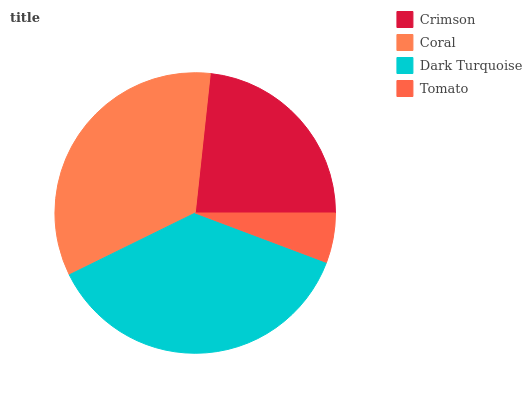Is Tomato the minimum?
Answer yes or no. Yes. Is Dark Turquoise the maximum?
Answer yes or no. Yes. Is Coral the minimum?
Answer yes or no. No. Is Coral the maximum?
Answer yes or no. No. Is Coral greater than Crimson?
Answer yes or no. Yes. Is Crimson less than Coral?
Answer yes or no. Yes. Is Crimson greater than Coral?
Answer yes or no. No. Is Coral less than Crimson?
Answer yes or no. No. Is Coral the high median?
Answer yes or no. Yes. Is Crimson the low median?
Answer yes or no. Yes. Is Dark Turquoise the high median?
Answer yes or no. No. Is Coral the low median?
Answer yes or no. No. 